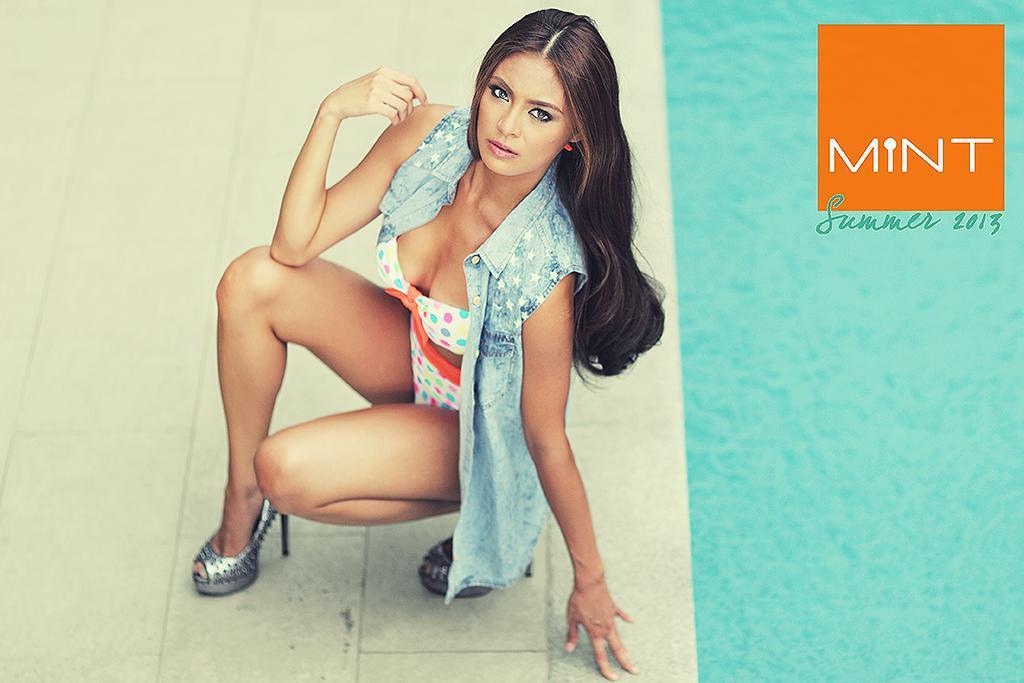Please provide a concise description of this image. In this picture we can see a poster. We can see a woman in a squat position and she is giving a pose. In the top right corner of the picture we can see text. 